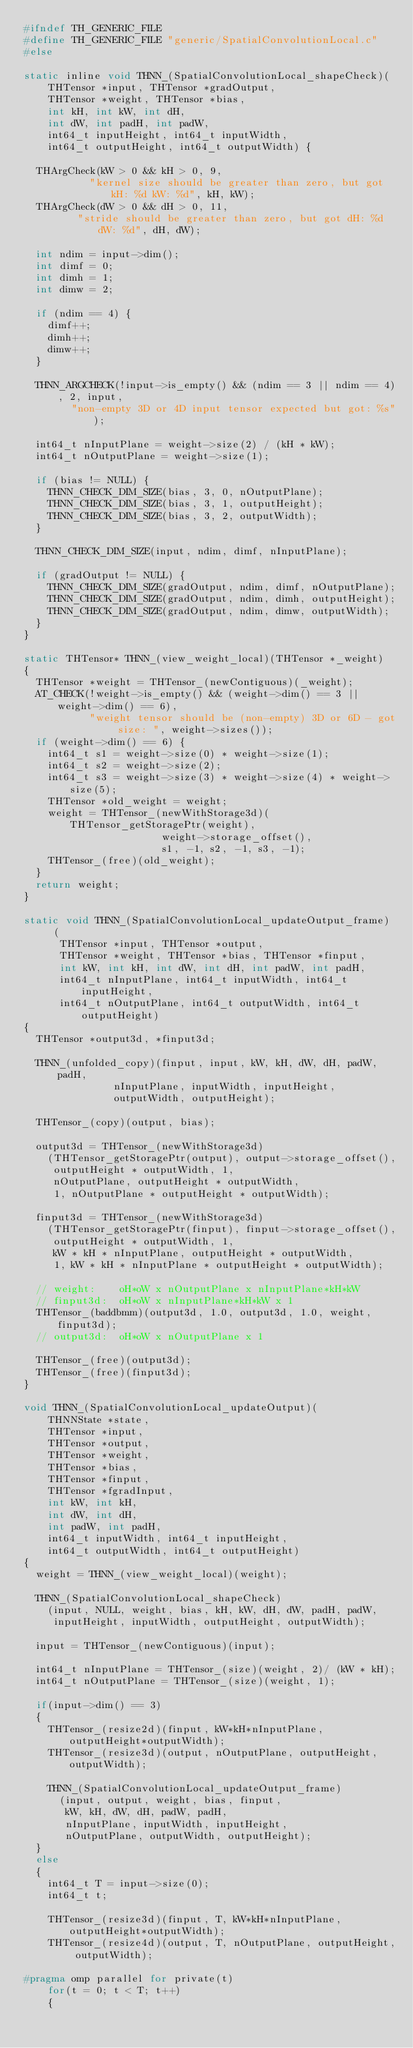<code> <loc_0><loc_0><loc_500><loc_500><_C_>#ifndef TH_GENERIC_FILE
#define TH_GENERIC_FILE "generic/SpatialConvolutionLocal.c"
#else

static inline void THNN_(SpatialConvolutionLocal_shapeCheck)(
    THTensor *input, THTensor *gradOutput,
    THTensor *weight, THTensor *bias,
    int kH, int kW, int dH,
    int dW, int padH, int padW,
    int64_t inputHeight, int64_t inputWidth,
    int64_t outputHeight, int64_t outputWidth) {

  THArgCheck(kW > 0 && kH > 0, 9,
           "kernel size should be greater than zero, but got kH: %d kW: %d", kH, kW);
  THArgCheck(dW > 0 && dH > 0, 11,
         "stride should be greater than zero, but got dH: %d dW: %d", dH, dW);

  int ndim = input->dim();
  int dimf = 0;
  int dimh = 1;
  int dimw = 2;

  if (ndim == 4) {
    dimf++;
    dimh++;
    dimw++;
  }

  THNN_ARGCHECK(!input->is_empty() && (ndim == 3 || ndim == 4), 2, input,
        "non-empty 3D or 4D input tensor expected but got: %s");

  int64_t nInputPlane = weight->size(2) / (kH * kW);
  int64_t nOutputPlane = weight->size(1);

  if (bias != NULL) {
    THNN_CHECK_DIM_SIZE(bias, 3, 0, nOutputPlane);
    THNN_CHECK_DIM_SIZE(bias, 3, 1, outputHeight);
    THNN_CHECK_DIM_SIZE(bias, 3, 2, outputWidth);
  }

  THNN_CHECK_DIM_SIZE(input, ndim, dimf, nInputPlane);

  if (gradOutput != NULL) {
    THNN_CHECK_DIM_SIZE(gradOutput, ndim, dimf, nOutputPlane);
    THNN_CHECK_DIM_SIZE(gradOutput, ndim, dimh, outputHeight);
    THNN_CHECK_DIM_SIZE(gradOutput, ndim, dimw, outputWidth);
  }
}

static THTensor* THNN_(view_weight_local)(THTensor *_weight)
{
  THTensor *weight = THTensor_(newContiguous)(_weight);
  AT_CHECK(!weight->is_empty() && (weight->dim() == 3 || weight->dim() == 6),
           "weight tensor should be (non-empty) 3D or 6D - got size: ", weight->sizes());
  if (weight->dim() == 6) {
    int64_t s1 = weight->size(0) * weight->size(1);
    int64_t s2 = weight->size(2);
    int64_t s3 = weight->size(3) * weight->size(4) * weight->size(5);
    THTensor *old_weight = weight;
    weight = THTensor_(newWithStorage3d)(THTensor_getStoragePtr(weight),
                       weight->storage_offset(),
                       s1, -1, s2, -1, s3, -1);
    THTensor_(free)(old_weight);
  }
  return weight;
}

static void THNN_(SpatialConvolutionLocal_updateOutput_frame)
     (
      THTensor *input, THTensor *output,
      THTensor *weight, THTensor *bias, THTensor *finput,
      int kW, int kH, int dW, int dH, int padW, int padH,
      int64_t nInputPlane, int64_t inputWidth, int64_t inputHeight,
      int64_t nOutputPlane, int64_t outputWidth, int64_t outputHeight)
{
  THTensor *output3d, *finput3d;

  THNN_(unfolded_copy)(finput, input, kW, kH, dW, dH, padW, padH,
               nInputPlane, inputWidth, inputHeight,
               outputWidth, outputHeight);

  THTensor_(copy)(output, bias);

  output3d = THTensor_(newWithStorage3d)
    (THTensor_getStoragePtr(output), output->storage_offset(),
     outputHeight * outputWidth, 1,
     nOutputPlane, outputHeight * outputWidth,
     1, nOutputPlane * outputHeight * outputWidth);

  finput3d = THTensor_(newWithStorage3d)
    (THTensor_getStoragePtr(finput), finput->storage_offset(),
     outputHeight * outputWidth, 1,
     kW * kH * nInputPlane, outputHeight * outputWidth,
     1, kW * kH * nInputPlane * outputHeight * outputWidth);

  // weight:    oH*oW x nOutputPlane x nInputPlane*kH*kW
  // finput3d:  oH*oW x nInputPlane*kH*kW x 1
  THTensor_(baddbmm)(output3d, 1.0, output3d, 1.0, weight, finput3d);
  // output3d:  oH*oW x nOutputPlane x 1

  THTensor_(free)(output3d);
  THTensor_(free)(finput3d);
}

void THNN_(SpatialConvolutionLocal_updateOutput)(
    THNNState *state,
    THTensor *input,
    THTensor *output,
    THTensor *weight,
    THTensor *bias,
    THTensor *finput,
    THTensor *fgradInput,
    int kW, int kH,
    int dW, int dH,
    int padW, int padH,
    int64_t inputWidth, int64_t inputHeight,
    int64_t outputWidth, int64_t outputHeight)
{
  weight = THNN_(view_weight_local)(weight);

  THNN_(SpatialConvolutionLocal_shapeCheck)
    (input, NULL, weight, bias, kH, kW, dH, dW, padH, padW,
     inputHeight, inputWidth, outputHeight, outputWidth);

  input = THTensor_(newContiguous)(input);

  int64_t nInputPlane = THTensor_(size)(weight, 2)/ (kW * kH);
  int64_t nOutputPlane = THTensor_(size)(weight, 1);

  if(input->dim() == 3)
  {
    THTensor_(resize2d)(finput, kW*kH*nInputPlane, outputHeight*outputWidth);
    THTensor_(resize3d)(output, nOutputPlane, outputHeight, outputWidth);

    THNN_(SpatialConvolutionLocal_updateOutput_frame)
      (input, output, weight, bias, finput,
       kW, kH, dW, dH, padW, padH,
       nInputPlane, inputWidth, inputHeight,
       nOutputPlane, outputWidth, outputHeight);
  }
  else
  {
    int64_t T = input->size(0);
    int64_t t;

    THTensor_(resize3d)(finput, T, kW*kH*nInputPlane, outputHeight*outputWidth);
    THTensor_(resize4d)(output, T, nOutputPlane, outputHeight, outputWidth);

#pragma omp parallel for private(t)
    for(t = 0; t < T; t++)
    {</code> 